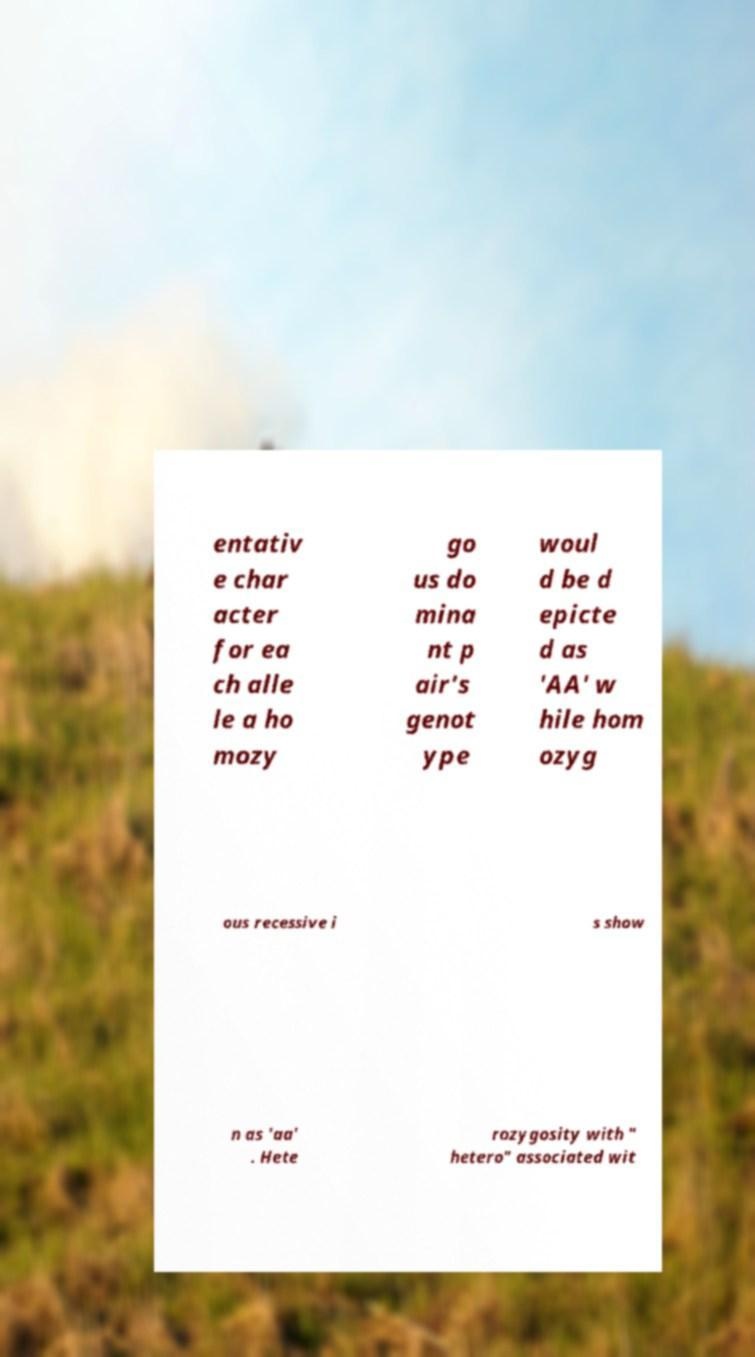Please identify and transcribe the text found in this image. entativ e char acter for ea ch alle le a ho mozy go us do mina nt p air's genot ype woul d be d epicte d as 'AA' w hile hom ozyg ous recessive i s show n as 'aa' . Hete rozygosity with " hetero" associated wit 